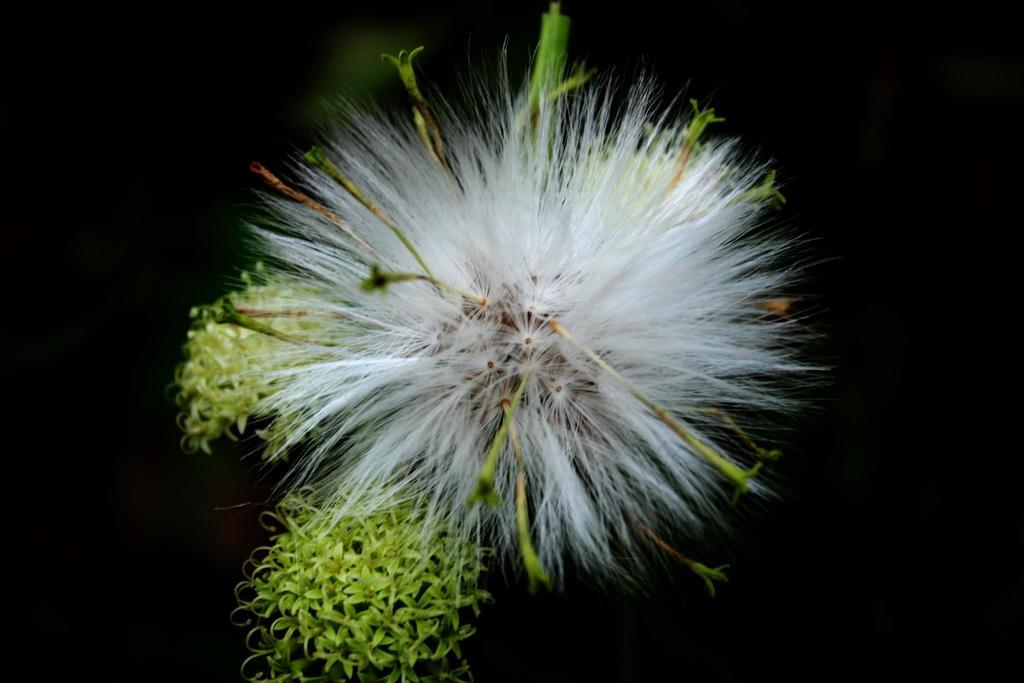What is the main subject in the center of the image? There is a dandelion in the center of the image. What type of flowers can be seen in the image besides the dandelion? There are green colored flowers in the image. How would you describe the overall color scheme of the image? The background of the image is dark. Can you see a frog looking at the dandelion in the image? There is no frog present in the image, and therefore no such activity can be observed. What type of beast is hiding behind the green flowers in the image? There is no beast present in the image; only the dandelion and green flowers are visible. 